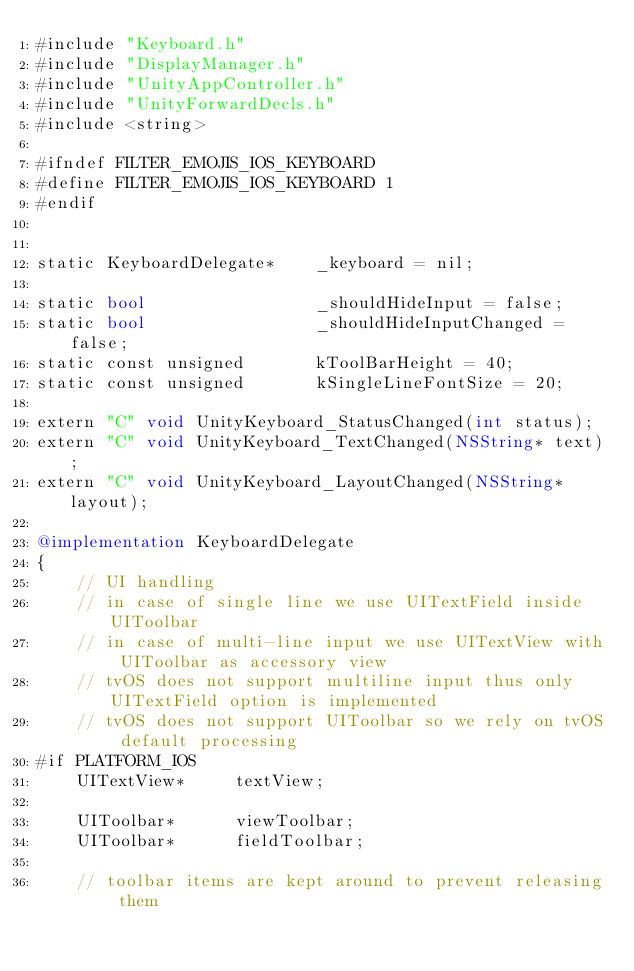Convert code to text. <code><loc_0><loc_0><loc_500><loc_500><_ObjectiveC_>#include "Keyboard.h"
#include "DisplayManager.h"
#include "UnityAppController.h"
#include "UnityForwardDecls.h"
#include <string>

#ifndef FILTER_EMOJIS_IOS_KEYBOARD
#define FILTER_EMOJIS_IOS_KEYBOARD 1
#endif


static KeyboardDelegate*    _keyboard = nil;

static bool                 _shouldHideInput = false;
static bool                 _shouldHideInputChanged = false;
static const unsigned       kToolBarHeight = 40;
static const unsigned       kSingleLineFontSize = 20;

extern "C" void UnityKeyboard_StatusChanged(int status);
extern "C" void UnityKeyboard_TextChanged(NSString* text);
extern "C" void UnityKeyboard_LayoutChanged(NSString* layout);

@implementation KeyboardDelegate
{
    // UI handling
    // in case of single line we use UITextField inside UIToolbar
    // in case of multi-line input we use UITextView with UIToolbar as accessory view
    // tvOS does not support multiline input thus only UITextField option is implemented
    // tvOS does not support UIToolbar so we rely on tvOS default processing
#if PLATFORM_IOS
    UITextView*     textView;

    UIToolbar*      viewToolbar;
    UIToolbar*      fieldToolbar;

    // toolbar items are kept around to prevent releasing them</code> 